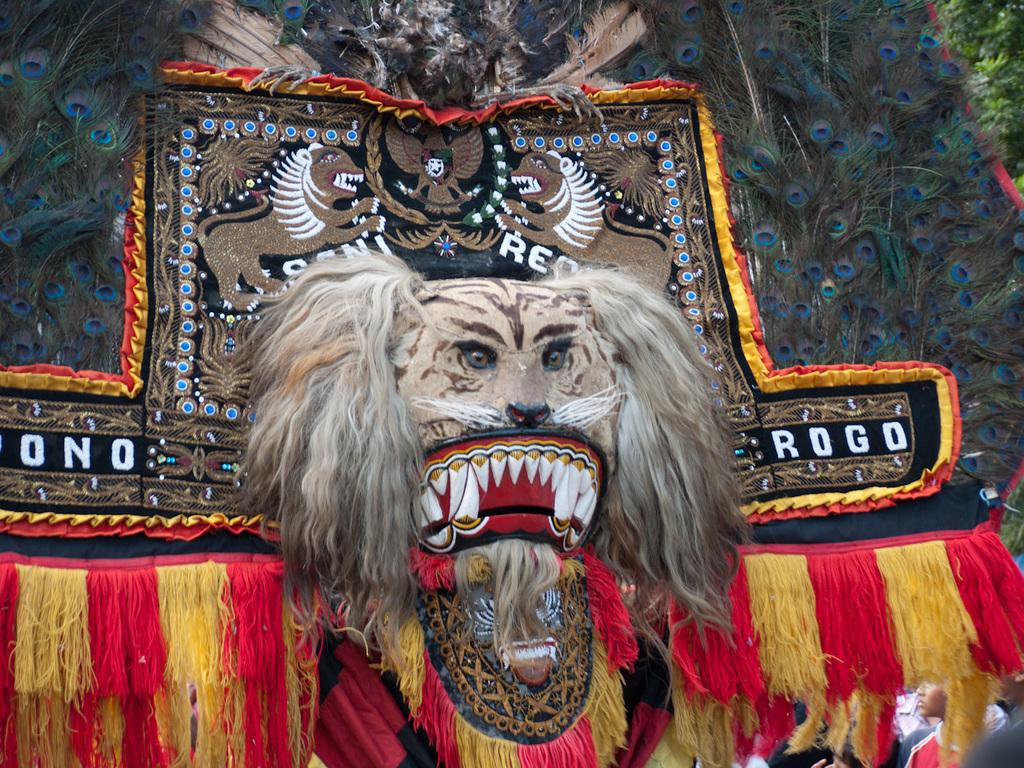What type of object is in the image? There is an animal mask in the image. Can you describe the appearance of the mask? The mask is in different colors, and there are peacock feathers on both sides of the mask. What else can be seen in the image? There is a tree visible in the image. What type of worm can be seen crawling on the mask in the image? There is no worm present on the mask in the image. What attraction is nearby the tree in the image? The provided facts do not mention any attractions near the tree in the image. 